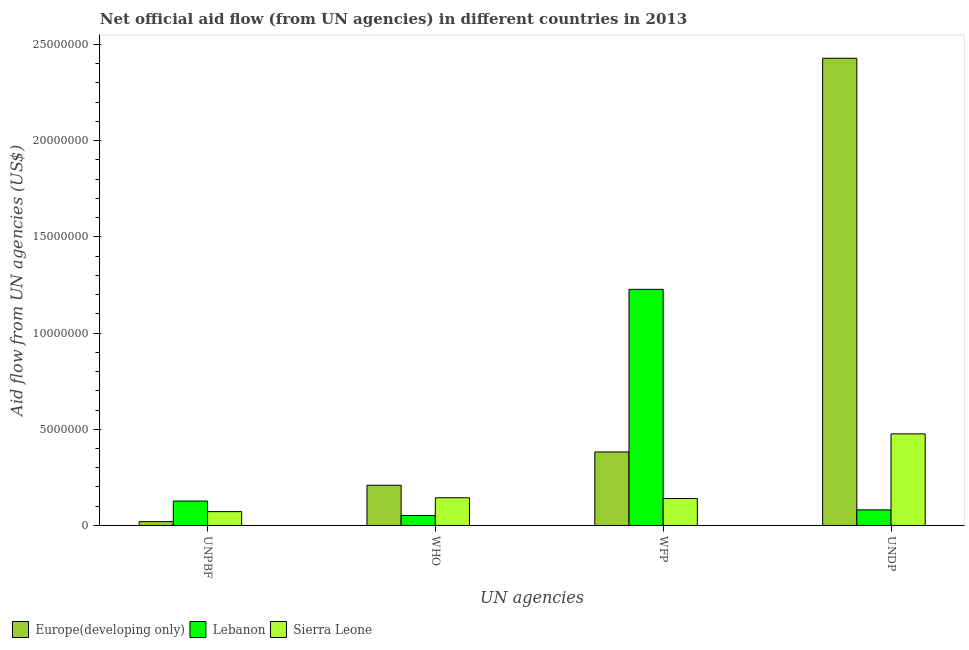How many different coloured bars are there?
Offer a terse response. 3. How many groups of bars are there?
Ensure brevity in your answer.  4. Are the number of bars per tick equal to the number of legend labels?
Offer a very short reply. Yes. How many bars are there on the 1st tick from the right?
Provide a succinct answer. 3. What is the label of the 1st group of bars from the left?
Offer a very short reply. UNPBF. What is the amount of aid given by who in Lebanon?
Your answer should be compact. 5.20e+05. Across all countries, what is the maximum amount of aid given by unpbf?
Provide a succinct answer. 1.27e+06. Across all countries, what is the minimum amount of aid given by who?
Keep it short and to the point. 5.20e+05. In which country was the amount of aid given by undp maximum?
Provide a short and direct response. Europe(developing only). In which country was the amount of aid given by undp minimum?
Give a very brief answer. Lebanon. What is the total amount of aid given by undp in the graph?
Offer a very short reply. 2.98e+07. What is the difference between the amount of aid given by undp in Europe(developing only) and that in Sierra Leone?
Make the answer very short. 1.95e+07. What is the difference between the amount of aid given by who in Europe(developing only) and the amount of aid given by undp in Sierra Leone?
Offer a very short reply. -2.67e+06. What is the average amount of aid given by unpbf per country?
Offer a very short reply. 7.30e+05. What is the difference between the amount of aid given by unpbf and amount of aid given by undp in Sierra Leone?
Your answer should be very brief. -4.04e+06. What is the ratio of the amount of aid given by unpbf in Lebanon to that in Europe(developing only)?
Keep it short and to the point. 6.35. Is the amount of aid given by undp in Europe(developing only) less than that in Sierra Leone?
Your response must be concise. No. Is the difference between the amount of aid given by wfp in Sierra Leone and Europe(developing only) greater than the difference between the amount of aid given by undp in Sierra Leone and Europe(developing only)?
Provide a short and direct response. Yes. What is the difference between the highest and the second highest amount of aid given by wfp?
Offer a terse response. 8.45e+06. What is the difference between the highest and the lowest amount of aid given by undp?
Offer a very short reply. 2.35e+07. Is the sum of the amount of aid given by unpbf in Europe(developing only) and Sierra Leone greater than the maximum amount of aid given by who across all countries?
Give a very brief answer. No. What does the 3rd bar from the left in WFP represents?
Make the answer very short. Sierra Leone. What does the 3rd bar from the right in WHO represents?
Offer a terse response. Europe(developing only). Is it the case that in every country, the sum of the amount of aid given by unpbf and amount of aid given by who is greater than the amount of aid given by wfp?
Provide a succinct answer. No. How many bars are there?
Provide a succinct answer. 12. Are all the bars in the graph horizontal?
Your answer should be compact. No. How many countries are there in the graph?
Keep it short and to the point. 3. Are the values on the major ticks of Y-axis written in scientific E-notation?
Offer a terse response. No. Does the graph contain any zero values?
Your answer should be compact. No. Does the graph contain grids?
Make the answer very short. No. How many legend labels are there?
Make the answer very short. 3. How are the legend labels stacked?
Provide a succinct answer. Horizontal. What is the title of the graph?
Offer a terse response. Net official aid flow (from UN agencies) in different countries in 2013. What is the label or title of the X-axis?
Ensure brevity in your answer.  UN agencies. What is the label or title of the Y-axis?
Your response must be concise. Aid flow from UN agencies (US$). What is the Aid flow from UN agencies (US$) of Lebanon in UNPBF?
Keep it short and to the point. 1.27e+06. What is the Aid flow from UN agencies (US$) in Sierra Leone in UNPBF?
Your response must be concise. 7.20e+05. What is the Aid flow from UN agencies (US$) in Europe(developing only) in WHO?
Your answer should be compact. 2.09e+06. What is the Aid flow from UN agencies (US$) in Lebanon in WHO?
Offer a terse response. 5.20e+05. What is the Aid flow from UN agencies (US$) in Sierra Leone in WHO?
Make the answer very short. 1.44e+06. What is the Aid flow from UN agencies (US$) of Europe(developing only) in WFP?
Ensure brevity in your answer.  3.82e+06. What is the Aid flow from UN agencies (US$) of Lebanon in WFP?
Your response must be concise. 1.23e+07. What is the Aid flow from UN agencies (US$) of Sierra Leone in WFP?
Offer a very short reply. 1.40e+06. What is the Aid flow from UN agencies (US$) of Europe(developing only) in UNDP?
Provide a short and direct response. 2.43e+07. What is the Aid flow from UN agencies (US$) in Lebanon in UNDP?
Your answer should be very brief. 8.10e+05. What is the Aid flow from UN agencies (US$) of Sierra Leone in UNDP?
Your response must be concise. 4.76e+06. Across all UN agencies, what is the maximum Aid flow from UN agencies (US$) in Europe(developing only)?
Give a very brief answer. 2.43e+07. Across all UN agencies, what is the maximum Aid flow from UN agencies (US$) of Lebanon?
Give a very brief answer. 1.23e+07. Across all UN agencies, what is the maximum Aid flow from UN agencies (US$) of Sierra Leone?
Provide a short and direct response. 4.76e+06. Across all UN agencies, what is the minimum Aid flow from UN agencies (US$) of Lebanon?
Your answer should be very brief. 5.20e+05. Across all UN agencies, what is the minimum Aid flow from UN agencies (US$) of Sierra Leone?
Offer a terse response. 7.20e+05. What is the total Aid flow from UN agencies (US$) in Europe(developing only) in the graph?
Your answer should be very brief. 3.04e+07. What is the total Aid flow from UN agencies (US$) in Lebanon in the graph?
Your answer should be very brief. 1.49e+07. What is the total Aid flow from UN agencies (US$) of Sierra Leone in the graph?
Give a very brief answer. 8.32e+06. What is the difference between the Aid flow from UN agencies (US$) of Europe(developing only) in UNPBF and that in WHO?
Your answer should be compact. -1.89e+06. What is the difference between the Aid flow from UN agencies (US$) of Lebanon in UNPBF and that in WHO?
Make the answer very short. 7.50e+05. What is the difference between the Aid flow from UN agencies (US$) of Sierra Leone in UNPBF and that in WHO?
Give a very brief answer. -7.20e+05. What is the difference between the Aid flow from UN agencies (US$) in Europe(developing only) in UNPBF and that in WFP?
Your answer should be very brief. -3.62e+06. What is the difference between the Aid flow from UN agencies (US$) in Lebanon in UNPBF and that in WFP?
Provide a short and direct response. -1.10e+07. What is the difference between the Aid flow from UN agencies (US$) in Sierra Leone in UNPBF and that in WFP?
Offer a very short reply. -6.80e+05. What is the difference between the Aid flow from UN agencies (US$) of Europe(developing only) in UNPBF and that in UNDP?
Your response must be concise. -2.41e+07. What is the difference between the Aid flow from UN agencies (US$) of Lebanon in UNPBF and that in UNDP?
Make the answer very short. 4.60e+05. What is the difference between the Aid flow from UN agencies (US$) of Sierra Leone in UNPBF and that in UNDP?
Your response must be concise. -4.04e+06. What is the difference between the Aid flow from UN agencies (US$) in Europe(developing only) in WHO and that in WFP?
Make the answer very short. -1.73e+06. What is the difference between the Aid flow from UN agencies (US$) in Lebanon in WHO and that in WFP?
Offer a terse response. -1.18e+07. What is the difference between the Aid flow from UN agencies (US$) in Europe(developing only) in WHO and that in UNDP?
Your answer should be very brief. -2.22e+07. What is the difference between the Aid flow from UN agencies (US$) of Sierra Leone in WHO and that in UNDP?
Provide a succinct answer. -3.32e+06. What is the difference between the Aid flow from UN agencies (US$) of Europe(developing only) in WFP and that in UNDP?
Your response must be concise. -2.05e+07. What is the difference between the Aid flow from UN agencies (US$) of Lebanon in WFP and that in UNDP?
Keep it short and to the point. 1.15e+07. What is the difference between the Aid flow from UN agencies (US$) of Sierra Leone in WFP and that in UNDP?
Your response must be concise. -3.36e+06. What is the difference between the Aid flow from UN agencies (US$) of Europe(developing only) in UNPBF and the Aid flow from UN agencies (US$) of Lebanon in WHO?
Your answer should be compact. -3.20e+05. What is the difference between the Aid flow from UN agencies (US$) of Europe(developing only) in UNPBF and the Aid flow from UN agencies (US$) of Sierra Leone in WHO?
Give a very brief answer. -1.24e+06. What is the difference between the Aid flow from UN agencies (US$) of Lebanon in UNPBF and the Aid flow from UN agencies (US$) of Sierra Leone in WHO?
Make the answer very short. -1.70e+05. What is the difference between the Aid flow from UN agencies (US$) in Europe(developing only) in UNPBF and the Aid flow from UN agencies (US$) in Lebanon in WFP?
Your answer should be compact. -1.21e+07. What is the difference between the Aid flow from UN agencies (US$) of Europe(developing only) in UNPBF and the Aid flow from UN agencies (US$) of Sierra Leone in WFP?
Your answer should be compact. -1.20e+06. What is the difference between the Aid flow from UN agencies (US$) of Lebanon in UNPBF and the Aid flow from UN agencies (US$) of Sierra Leone in WFP?
Provide a short and direct response. -1.30e+05. What is the difference between the Aid flow from UN agencies (US$) of Europe(developing only) in UNPBF and the Aid flow from UN agencies (US$) of Lebanon in UNDP?
Your answer should be compact. -6.10e+05. What is the difference between the Aid flow from UN agencies (US$) of Europe(developing only) in UNPBF and the Aid flow from UN agencies (US$) of Sierra Leone in UNDP?
Your response must be concise. -4.56e+06. What is the difference between the Aid flow from UN agencies (US$) in Lebanon in UNPBF and the Aid flow from UN agencies (US$) in Sierra Leone in UNDP?
Ensure brevity in your answer.  -3.49e+06. What is the difference between the Aid flow from UN agencies (US$) of Europe(developing only) in WHO and the Aid flow from UN agencies (US$) of Lebanon in WFP?
Provide a succinct answer. -1.02e+07. What is the difference between the Aid flow from UN agencies (US$) in Europe(developing only) in WHO and the Aid flow from UN agencies (US$) in Sierra Leone in WFP?
Ensure brevity in your answer.  6.90e+05. What is the difference between the Aid flow from UN agencies (US$) in Lebanon in WHO and the Aid flow from UN agencies (US$) in Sierra Leone in WFP?
Your answer should be compact. -8.80e+05. What is the difference between the Aid flow from UN agencies (US$) in Europe(developing only) in WHO and the Aid flow from UN agencies (US$) in Lebanon in UNDP?
Keep it short and to the point. 1.28e+06. What is the difference between the Aid flow from UN agencies (US$) in Europe(developing only) in WHO and the Aid flow from UN agencies (US$) in Sierra Leone in UNDP?
Your answer should be compact. -2.67e+06. What is the difference between the Aid flow from UN agencies (US$) of Lebanon in WHO and the Aid flow from UN agencies (US$) of Sierra Leone in UNDP?
Provide a short and direct response. -4.24e+06. What is the difference between the Aid flow from UN agencies (US$) in Europe(developing only) in WFP and the Aid flow from UN agencies (US$) in Lebanon in UNDP?
Your answer should be very brief. 3.01e+06. What is the difference between the Aid flow from UN agencies (US$) in Europe(developing only) in WFP and the Aid flow from UN agencies (US$) in Sierra Leone in UNDP?
Provide a succinct answer. -9.40e+05. What is the difference between the Aid flow from UN agencies (US$) in Lebanon in WFP and the Aid flow from UN agencies (US$) in Sierra Leone in UNDP?
Keep it short and to the point. 7.51e+06. What is the average Aid flow from UN agencies (US$) in Europe(developing only) per UN agencies?
Offer a terse response. 7.60e+06. What is the average Aid flow from UN agencies (US$) of Lebanon per UN agencies?
Offer a terse response. 3.72e+06. What is the average Aid flow from UN agencies (US$) of Sierra Leone per UN agencies?
Your answer should be compact. 2.08e+06. What is the difference between the Aid flow from UN agencies (US$) of Europe(developing only) and Aid flow from UN agencies (US$) of Lebanon in UNPBF?
Your response must be concise. -1.07e+06. What is the difference between the Aid flow from UN agencies (US$) in Europe(developing only) and Aid flow from UN agencies (US$) in Sierra Leone in UNPBF?
Ensure brevity in your answer.  -5.20e+05. What is the difference between the Aid flow from UN agencies (US$) of Europe(developing only) and Aid flow from UN agencies (US$) of Lebanon in WHO?
Provide a succinct answer. 1.57e+06. What is the difference between the Aid flow from UN agencies (US$) of Europe(developing only) and Aid flow from UN agencies (US$) of Sierra Leone in WHO?
Provide a short and direct response. 6.50e+05. What is the difference between the Aid flow from UN agencies (US$) in Lebanon and Aid flow from UN agencies (US$) in Sierra Leone in WHO?
Your response must be concise. -9.20e+05. What is the difference between the Aid flow from UN agencies (US$) of Europe(developing only) and Aid flow from UN agencies (US$) of Lebanon in WFP?
Ensure brevity in your answer.  -8.45e+06. What is the difference between the Aid flow from UN agencies (US$) of Europe(developing only) and Aid flow from UN agencies (US$) of Sierra Leone in WFP?
Provide a succinct answer. 2.42e+06. What is the difference between the Aid flow from UN agencies (US$) of Lebanon and Aid flow from UN agencies (US$) of Sierra Leone in WFP?
Give a very brief answer. 1.09e+07. What is the difference between the Aid flow from UN agencies (US$) in Europe(developing only) and Aid flow from UN agencies (US$) in Lebanon in UNDP?
Your answer should be compact. 2.35e+07. What is the difference between the Aid flow from UN agencies (US$) in Europe(developing only) and Aid flow from UN agencies (US$) in Sierra Leone in UNDP?
Ensure brevity in your answer.  1.95e+07. What is the difference between the Aid flow from UN agencies (US$) of Lebanon and Aid flow from UN agencies (US$) of Sierra Leone in UNDP?
Your response must be concise. -3.95e+06. What is the ratio of the Aid flow from UN agencies (US$) in Europe(developing only) in UNPBF to that in WHO?
Provide a short and direct response. 0.1. What is the ratio of the Aid flow from UN agencies (US$) in Lebanon in UNPBF to that in WHO?
Give a very brief answer. 2.44. What is the ratio of the Aid flow from UN agencies (US$) of Sierra Leone in UNPBF to that in WHO?
Keep it short and to the point. 0.5. What is the ratio of the Aid flow from UN agencies (US$) in Europe(developing only) in UNPBF to that in WFP?
Your answer should be compact. 0.05. What is the ratio of the Aid flow from UN agencies (US$) in Lebanon in UNPBF to that in WFP?
Provide a succinct answer. 0.1. What is the ratio of the Aid flow from UN agencies (US$) in Sierra Leone in UNPBF to that in WFP?
Give a very brief answer. 0.51. What is the ratio of the Aid flow from UN agencies (US$) in Europe(developing only) in UNPBF to that in UNDP?
Give a very brief answer. 0.01. What is the ratio of the Aid flow from UN agencies (US$) of Lebanon in UNPBF to that in UNDP?
Offer a very short reply. 1.57. What is the ratio of the Aid flow from UN agencies (US$) of Sierra Leone in UNPBF to that in UNDP?
Your response must be concise. 0.15. What is the ratio of the Aid flow from UN agencies (US$) in Europe(developing only) in WHO to that in WFP?
Provide a short and direct response. 0.55. What is the ratio of the Aid flow from UN agencies (US$) in Lebanon in WHO to that in WFP?
Your answer should be very brief. 0.04. What is the ratio of the Aid flow from UN agencies (US$) of Sierra Leone in WHO to that in WFP?
Your answer should be compact. 1.03. What is the ratio of the Aid flow from UN agencies (US$) of Europe(developing only) in WHO to that in UNDP?
Keep it short and to the point. 0.09. What is the ratio of the Aid flow from UN agencies (US$) in Lebanon in WHO to that in UNDP?
Ensure brevity in your answer.  0.64. What is the ratio of the Aid flow from UN agencies (US$) in Sierra Leone in WHO to that in UNDP?
Make the answer very short. 0.3. What is the ratio of the Aid flow from UN agencies (US$) in Europe(developing only) in WFP to that in UNDP?
Your answer should be compact. 0.16. What is the ratio of the Aid flow from UN agencies (US$) in Lebanon in WFP to that in UNDP?
Your answer should be compact. 15.15. What is the ratio of the Aid flow from UN agencies (US$) of Sierra Leone in WFP to that in UNDP?
Ensure brevity in your answer.  0.29. What is the difference between the highest and the second highest Aid flow from UN agencies (US$) in Europe(developing only)?
Offer a very short reply. 2.05e+07. What is the difference between the highest and the second highest Aid flow from UN agencies (US$) of Lebanon?
Offer a terse response. 1.10e+07. What is the difference between the highest and the second highest Aid flow from UN agencies (US$) in Sierra Leone?
Offer a terse response. 3.32e+06. What is the difference between the highest and the lowest Aid flow from UN agencies (US$) in Europe(developing only)?
Provide a short and direct response. 2.41e+07. What is the difference between the highest and the lowest Aid flow from UN agencies (US$) of Lebanon?
Your response must be concise. 1.18e+07. What is the difference between the highest and the lowest Aid flow from UN agencies (US$) in Sierra Leone?
Give a very brief answer. 4.04e+06. 